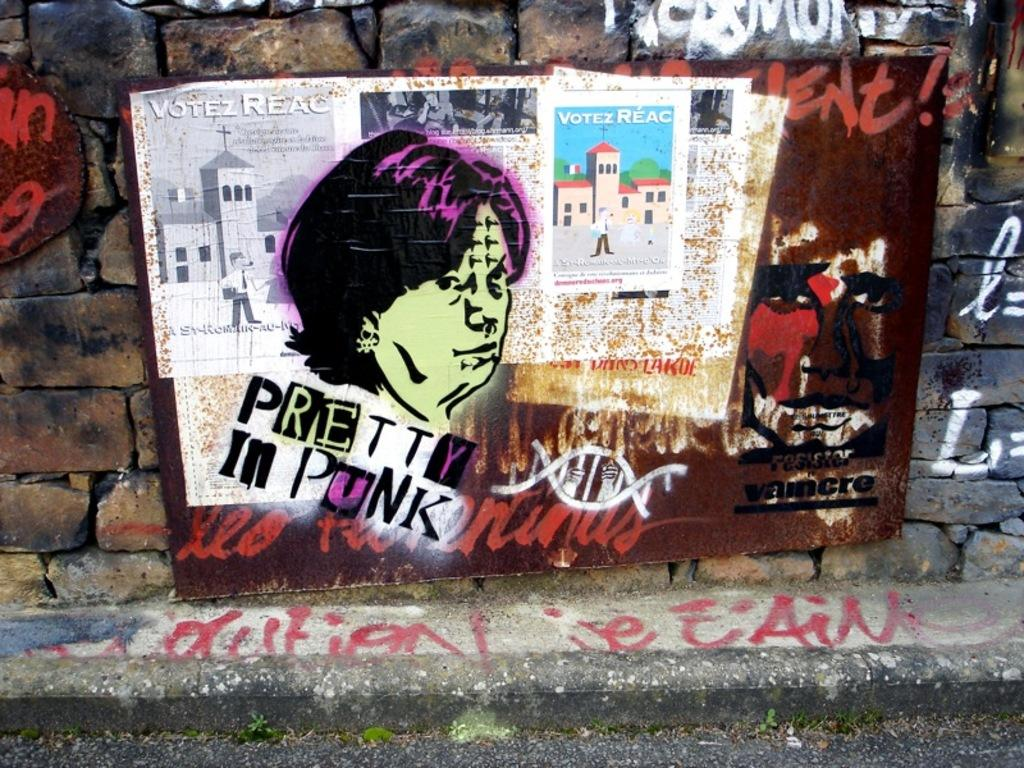<image>
Summarize the visual content of the image. Graffiti on a city brick wall for punks and violence. 